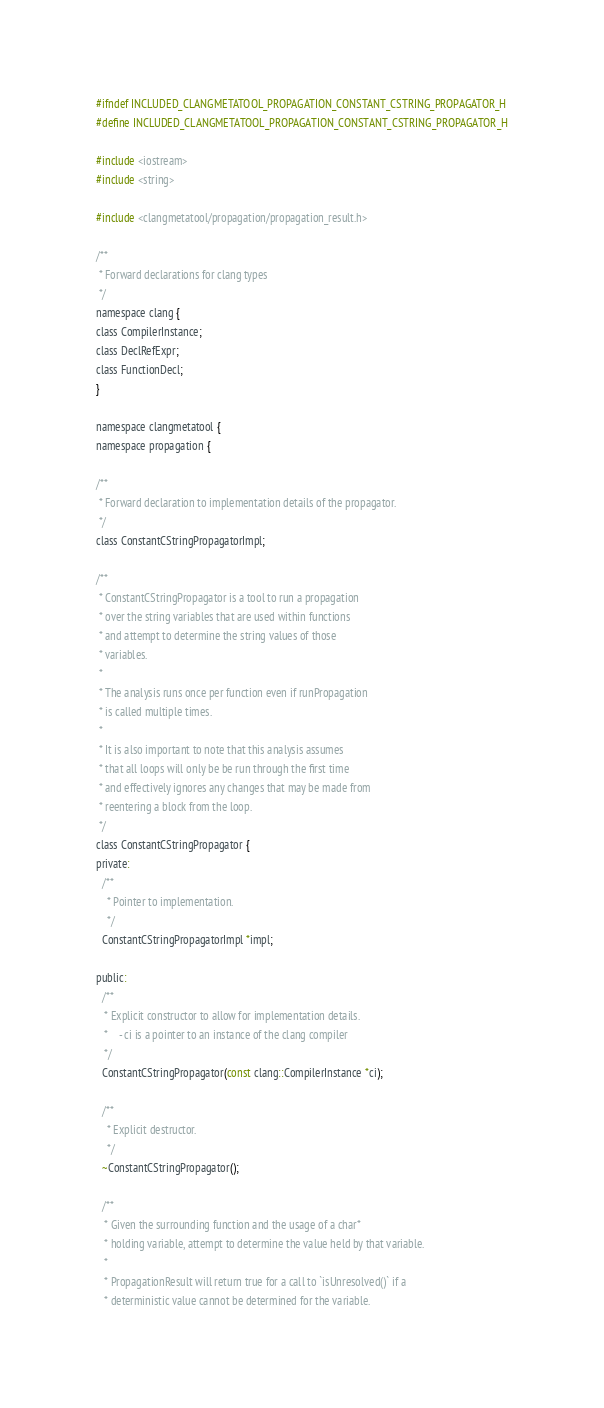<code> <loc_0><loc_0><loc_500><loc_500><_C_>#ifndef INCLUDED_CLANGMETATOOL_PROPAGATION_CONSTANT_CSTRING_PROPAGATOR_H
#define INCLUDED_CLANGMETATOOL_PROPAGATION_CONSTANT_CSTRING_PROPAGATOR_H

#include <iostream>
#include <string>

#include <clangmetatool/propagation/propagation_result.h>

/**
 * Forward declarations for clang types
 */
namespace clang {
class CompilerInstance;
class DeclRefExpr;
class FunctionDecl;
}

namespace clangmetatool {
namespace propagation {

/**
 * Forward declaration to implementation details of the propagator.
 */
class ConstantCStringPropagatorImpl;

/**
 * ConstantCStringPropagator is a tool to run a propagation
 * over the string variables that are used within functions
 * and attempt to determine the string values of those
 * variables.
 *
 * The analysis runs once per function even if runPropagation
 * is called multiple times.
 *
 * It is also important to note that this analysis assumes
 * that all loops will only be be run through the first time
 * and effectively ignores any changes that may be made from
 * reentering a block from the loop.
 */
class ConstantCStringPropagator {
private:
  /**
    * Pointer to implementation.
    */
  ConstantCStringPropagatorImpl *impl;

public:
  /**
   * Explicit constructor to allow for implementation details.
   *    - ci is a pointer to an instance of the clang compiler
   */
  ConstantCStringPropagator(const clang::CompilerInstance *ci);

  /**
    * Explicit destructor.
    */
  ~ConstantCStringPropagator();

  /**
   * Given the surrounding function and the usage of a char*
   * holding variable, attempt to determine the value held by that variable.
   *
   * PropagationResult will return true for a call to `isUnresolved()` if a
   * deterministic value cannot be determined for the variable.</code> 